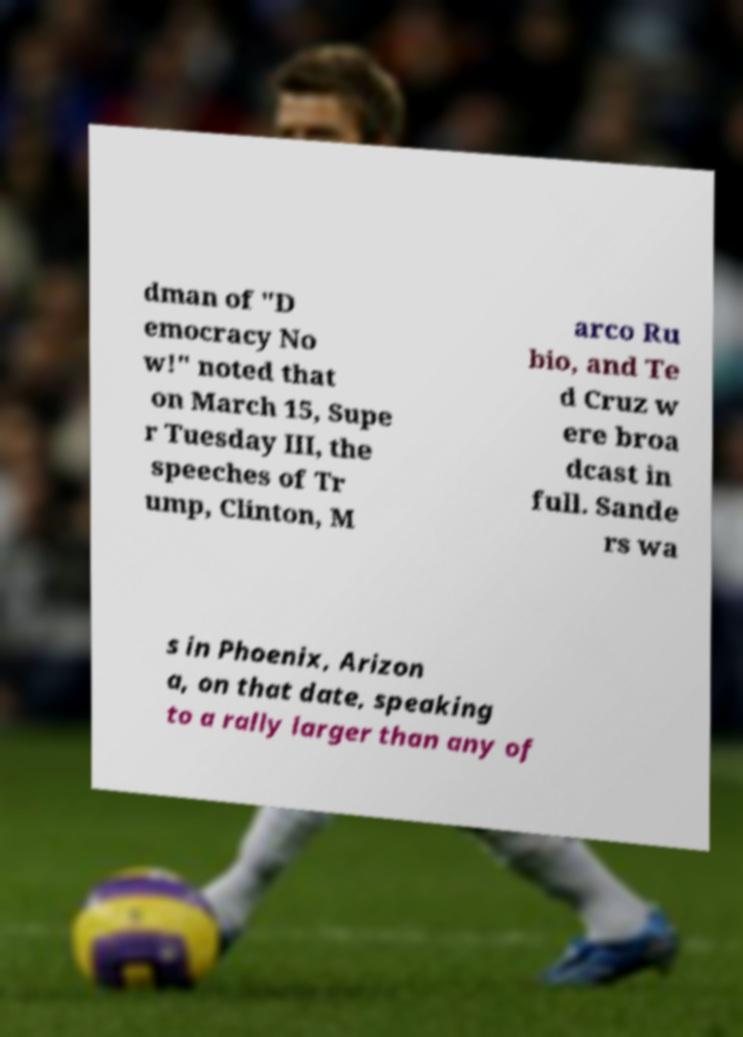What messages or text are displayed in this image? I need them in a readable, typed format. dman of "D emocracy No w!" noted that on March 15, Supe r Tuesday III, the speeches of Tr ump, Clinton, M arco Ru bio, and Te d Cruz w ere broa dcast in full. Sande rs wa s in Phoenix, Arizon a, on that date, speaking to a rally larger than any of 